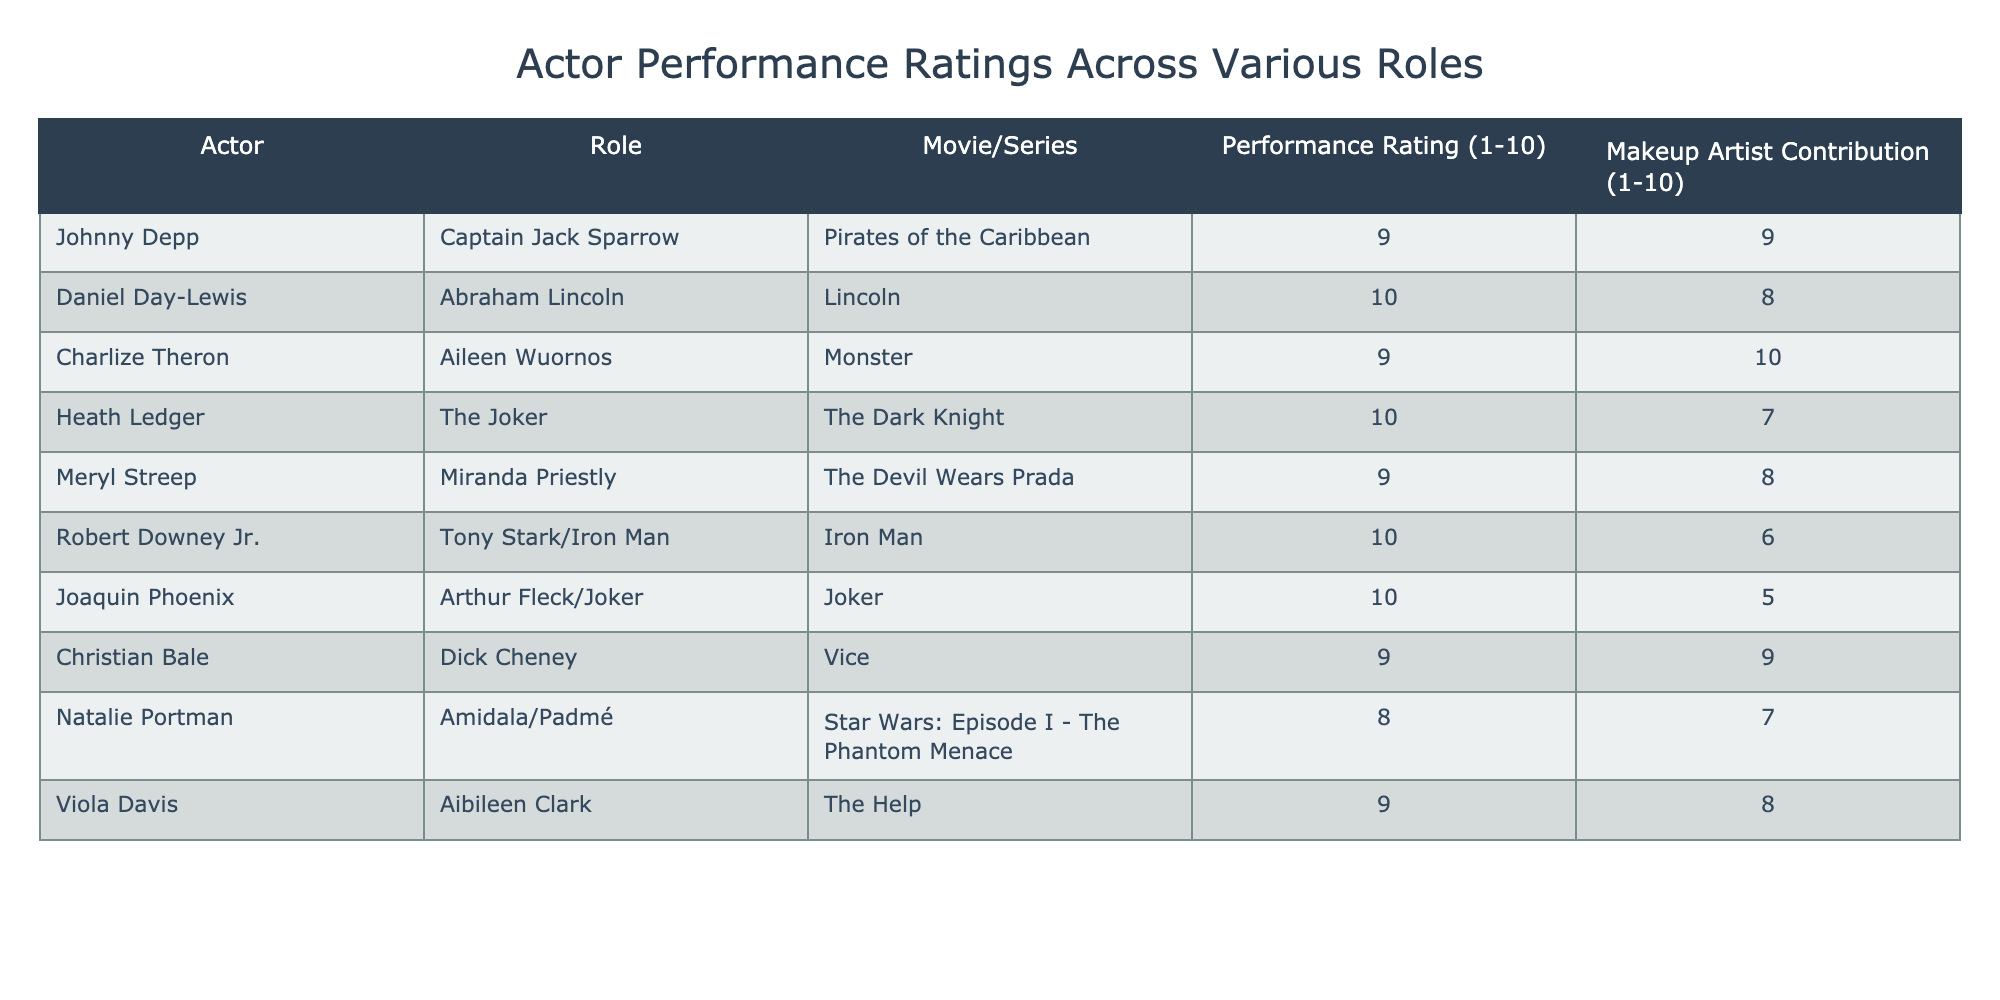What is the performance rating of Johnny Depp as Captain Jack Sparrow? Johnny Depp's performance rating as Captain Jack Sparrow in "Pirates of the Caribbean" is directly listed in the table. Looking at the row where Johnny Depp is mentioned, the performance rating column shows a score of 9.
Answer: 9 Which actor has the highest performance rating? To find the highest performance rating, I scan through the performance rating column for all actors. The maximum value found is 10, which is shared by Daniel Day-Lewis, Heath Ledger, and Joaquin Phoenix. Hence, these three actors have the highest performance rating of 10.
Answer: Daniel Day-Lewis, Heath Ledger, and Joaquin Phoenix Is Meryl Streep's performance rating higher than her makeup artist's contribution? For Meryl Streep, her performance rating is 9 and her makeup artist's contribution is 8. Since 9 is greater than 8, Meryl Streep's performance rating is indeed higher than her makeup artist's contribution.
Answer: Yes What is the average performance rating for the actors in this table? To calculate the average, I sum all performance ratings: (9 + 10 + 9 + 10 + 9 + 10 + 10 + 9 + 8 + 9) =  9.5. There are 10 actors, so the average is 95/10 = 9.5.
Answer: 9.5 Which actor's performance rating is closest to their makeup artist's contribution? To find the actor whose performance rating is closest to their makeup artist's contribution, I look at the difference between the two values for each actor. The closest match occurs with Christian Bale, who has a performance rating of 9 and a contribution of 9, resulting in a difference of 0, which is the smallest possible.
Answer: Christian Bale How does Charlize Theron's performance rating compare to that of Natalie Portman? Charlize Theron's performance rating is 9 while Natalie Portman's is 8. Since 9 is greater than 8, Charlize Theron's rating is higher than Natalie Portman's.
Answer: Charlize Theron is higher Is there an actor who received a performance rating of 8? I scan through the performance ratings in the table and find that Natalie Portman has a performance rating of 8. Therefore, yes, there is an actor with this rating.
Answer: Yes What is the total sum of the makeup artist contributions? I need to sum all the makeup artist contributions listed in the table: (9 + 8 + 10 + 7 + 8 + 6 + 5 + 9 + 7 + 8) = 78. This gives the total sum of contributions.
Answer: 78 Which actor has the lowest performance rating? I examine the performance ratings in the table to identify the lowest value. Natalie Portman has a performance rating of 8, which is the lowest among all listed.
Answer: Natalie Portman 